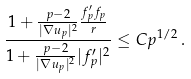Convert formula to latex. <formula><loc_0><loc_0><loc_500><loc_500>\frac { 1 + \frac { p - 2 } { | \nabla u _ { p } | ^ { 2 } } \frac { f _ { p } ^ { \prime } f _ { p } } { r } } { 1 + \frac { p - 2 } { | \nabla u _ { p } | ^ { 2 } } | f _ { p } ^ { \prime } | ^ { 2 } } \leq C p ^ { 1 / 2 } \, .</formula> 